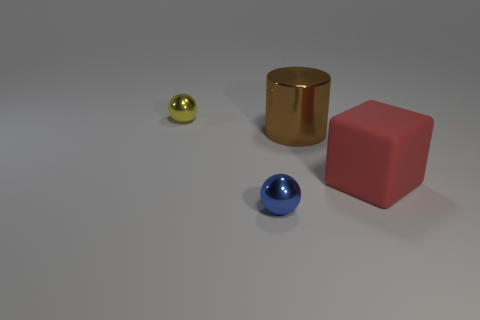How many cubes are either blue matte things or blue metallic objects? In the image, there are no cubes that fit the description of being blue and either matte or metallic. There is, however, a blue spherical object that appears to have a glossy or metallic finish and there are other objects that are not blue cubes, including a pink matte cube and a golden metallic cylinder. 